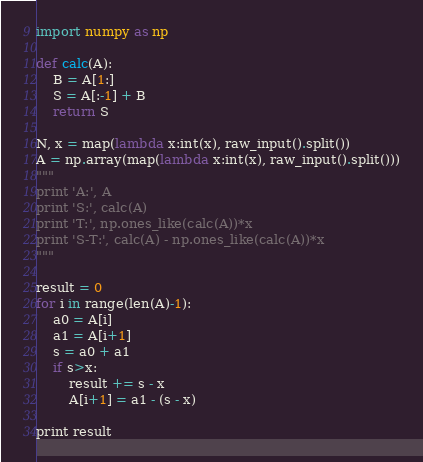<code> <loc_0><loc_0><loc_500><loc_500><_Python_>import numpy as np

def calc(A):
    B = A[1:]
    S = A[:-1] + B
    return S

N, x = map(lambda x:int(x), raw_input().split())
A = np.array(map(lambda x:int(x), raw_input().split()))
"""
print 'A:', A
print 'S:', calc(A)
print 'T:', np.ones_like(calc(A))*x
print 'S-T:', calc(A) - np.ones_like(calc(A))*x
"""

result = 0
for i in range(len(A)-1):
    a0 = A[i]
    a1 = A[i+1]
    s = a0 + a1
    if s>x:
        result += s - x
        A[i+1] = a1 - (s - x) 
    
print result</code> 